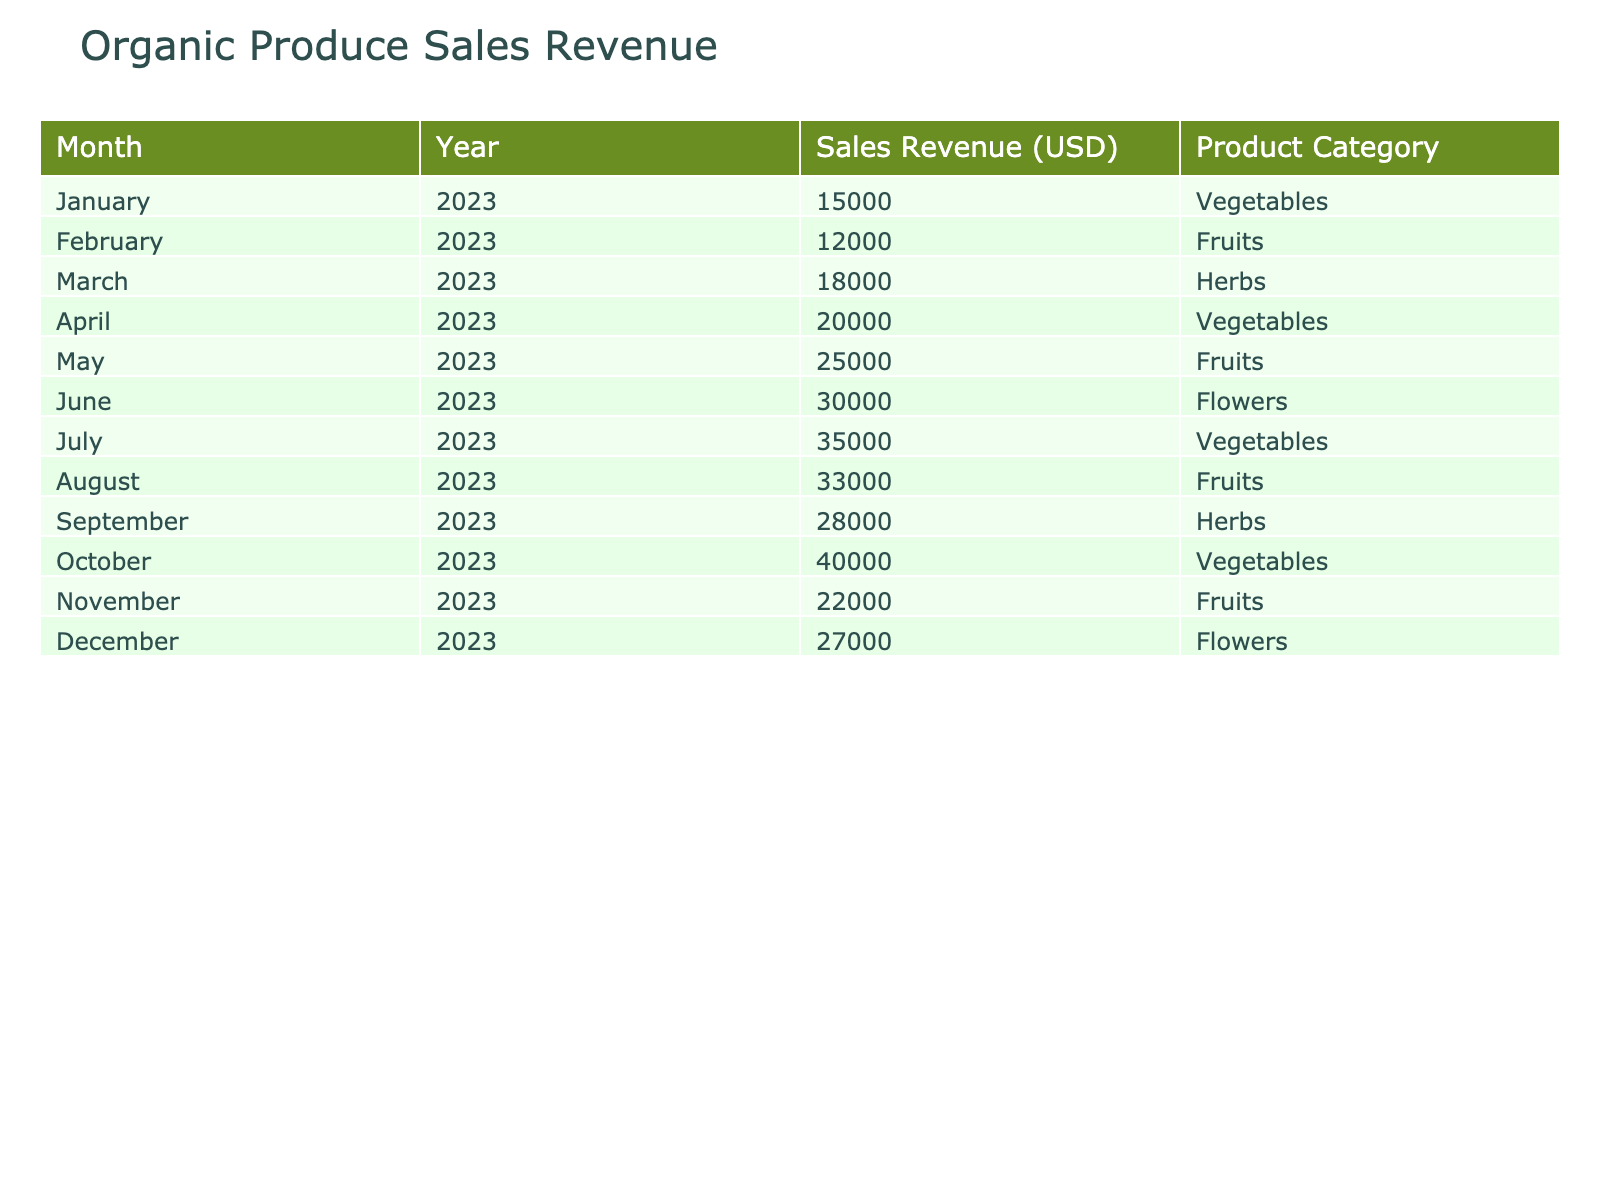What was the highest sales revenue recorded in the year 2023? The highest sales revenue can be found by looking through the "Sales Revenue (USD)" column. From the data, the highest value is 40000, which occurs in October.
Answer: 40000 What product category had the lowest sales revenue in February 2023? In February 2023, the product category was "Fruits" with a sales revenue of 12000. By comparing this with all other categories listed for that month, it is the only entry for that month.
Answer: Fruits What is the average sales revenue for vegetables sold in 2023? To calculate the average for vegetables, we will take the sales revenue for the vegetable months: January (15000), April (20000), July (35000), and October (40000). The sum is 15000 + 20000 + 35000 + 40000 = 110000. There are 4 months, so the average is 110000 / 4 = 27500.
Answer: 27500 Did sales revenue for flowers exceed that of herbs in September 2023? In September 2023, sales revenue for herbs is 28000, and for flowers, it is not recorded as a product category that month. Therefore, it is considered to be 0, hence it does not exceed 28000.
Answer: No What was the total sales revenue from fruits for the entire year? To find the total sales revenue for fruits, we will sum the values from the months they were sold: February (12000), May (25000), August (33000), and November (22000). The total is 12000 + 25000 + 33000 + 22000 = 92000.
Answer: 92000 Was there any month in 2023 where the sales revenue from flowers was the highest? From the data, flowers are recorded for June (30000) and December (27000) and comparing these values indicates that June had the highest sales revenue in that category, but it was not the highest overall for 2023.
Answer: No What is the difference in sales revenue between the highest and lowest months for fruits? The highest month for fruits is May (25000) and the lowest is February (12000). The difference is calculated as 25000 - 12000 = 13000.
Answer: 13000 During which month was the second highest sales revenue recorded, and what was that amount? The highest sales revenue recorded is in October (40000), so the second highest must be identified by looking for the next highest value which is in July (35000). Thus the month is July and the amount is 35000.
Answer: July, 35000 